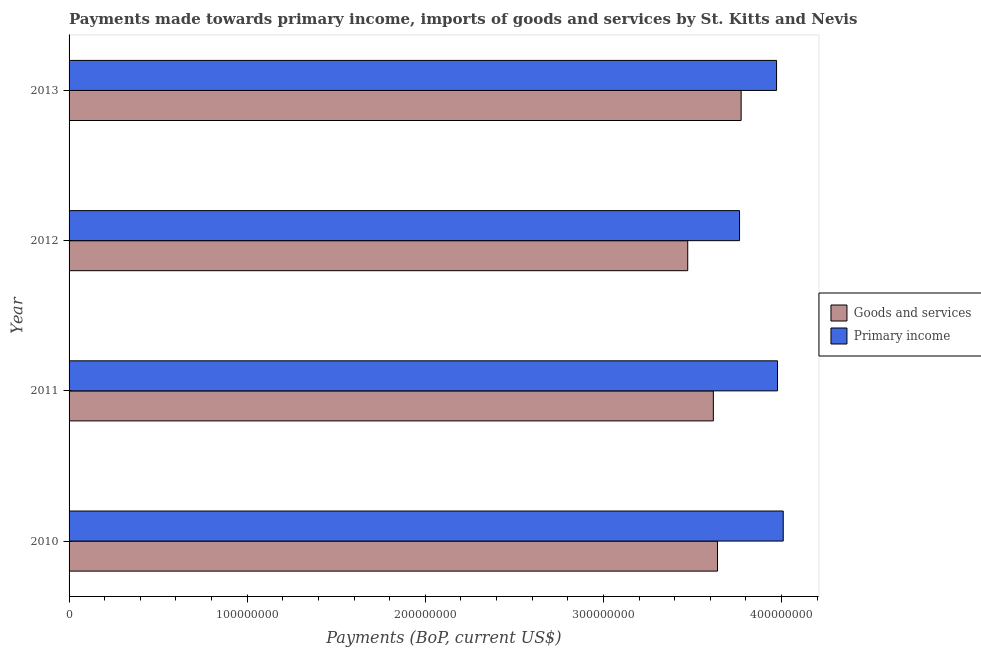How many groups of bars are there?
Offer a terse response. 4. Are the number of bars on each tick of the Y-axis equal?
Keep it short and to the point. Yes. How many bars are there on the 1st tick from the top?
Your response must be concise. 2. What is the label of the 2nd group of bars from the top?
Ensure brevity in your answer.  2012. In how many cases, is the number of bars for a given year not equal to the number of legend labels?
Make the answer very short. 0. What is the payments made towards goods and services in 2013?
Your answer should be very brief. 3.77e+08. Across all years, what is the maximum payments made towards primary income?
Your answer should be compact. 4.01e+08. Across all years, what is the minimum payments made towards primary income?
Give a very brief answer. 3.76e+08. In which year was the payments made towards goods and services maximum?
Make the answer very short. 2013. In which year was the payments made towards primary income minimum?
Provide a succinct answer. 2012. What is the total payments made towards primary income in the graph?
Provide a short and direct response. 1.57e+09. What is the difference between the payments made towards goods and services in 2011 and that in 2012?
Keep it short and to the point. 1.44e+07. What is the difference between the payments made towards primary income in 2011 and the payments made towards goods and services in 2013?
Give a very brief answer. 2.04e+07. What is the average payments made towards goods and services per year?
Give a very brief answer. 3.63e+08. In the year 2012, what is the difference between the payments made towards primary income and payments made towards goods and services?
Keep it short and to the point. 2.91e+07. Is the payments made towards primary income in 2010 less than that in 2013?
Your response must be concise. No. Is the difference between the payments made towards goods and services in 2010 and 2012 greater than the difference between the payments made towards primary income in 2010 and 2012?
Your answer should be very brief. No. What is the difference between the highest and the second highest payments made towards primary income?
Ensure brevity in your answer.  3.21e+06. What is the difference between the highest and the lowest payments made towards goods and services?
Offer a terse response. 3.00e+07. What does the 1st bar from the top in 2012 represents?
Offer a very short reply. Primary income. What does the 1st bar from the bottom in 2013 represents?
Your answer should be compact. Goods and services. Are all the bars in the graph horizontal?
Your answer should be compact. Yes. How many years are there in the graph?
Provide a short and direct response. 4. What is the difference between two consecutive major ticks on the X-axis?
Give a very brief answer. 1.00e+08. Are the values on the major ticks of X-axis written in scientific E-notation?
Make the answer very short. No. Does the graph contain any zero values?
Provide a short and direct response. No. How many legend labels are there?
Ensure brevity in your answer.  2. What is the title of the graph?
Provide a succinct answer. Payments made towards primary income, imports of goods and services by St. Kitts and Nevis. Does "Agricultural land" appear as one of the legend labels in the graph?
Provide a short and direct response. No. What is the label or title of the X-axis?
Your answer should be compact. Payments (BoP, current US$). What is the Payments (BoP, current US$) in Goods and services in 2010?
Keep it short and to the point. 3.64e+08. What is the Payments (BoP, current US$) of Primary income in 2010?
Your response must be concise. 4.01e+08. What is the Payments (BoP, current US$) of Goods and services in 2011?
Provide a succinct answer. 3.62e+08. What is the Payments (BoP, current US$) in Primary income in 2011?
Provide a succinct answer. 3.98e+08. What is the Payments (BoP, current US$) of Goods and services in 2012?
Ensure brevity in your answer.  3.47e+08. What is the Payments (BoP, current US$) in Primary income in 2012?
Provide a short and direct response. 3.76e+08. What is the Payments (BoP, current US$) in Goods and services in 2013?
Provide a short and direct response. 3.77e+08. What is the Payments (BoP, current US$) of Primary income in 2013?
Your answer should be compact. 3.97e+08. Across all years, what is the maximum Payments (BoP, current US$) of Goods and services?
Your answer should be compact. 3.77e+08. Across all years, what is the maximum Payments (BoP, current US$) of Primary income?
Offer a terse response. 4.01e+08. Across all years, what is the minimum Payments (BoP, current US$) in Goods and services?
Your answer should be very brief. 3.47e+08. Across all years, what is the minimum Payments (BoP, current US$) in Primary income?
Ensure brevity in your answer.  3.76e+08. What is the total Payments (BoP, current US$) in Goods and services in the graph?
Give a very brief answer. 1.45e+09. What is the total Payments (BoP, current US$) in Primary income in the graph?
Make the answer very short. 1.57e+09. What is the difference between the Payments (BoP, current US$) in Goods and services in 2010 and that in 2011?
Your response must be concise. 2.35e+06. What is the difference between the Payments (BoP, current US$) in Primary income in 2010 and that in 2011?
Ensure brevity in your answer.  3.21e+06. What is the difference between the Payments (BoP, current US$) of Goods and services in 2010 and that in 2012?
Keep it short and to the point. 1.67e+07. What is the difference between the Payments (BoP, current US$) of Primary income in 2010 and that in 2012?
Provide a succinct answer. 2.45e+07. What is the difference between the Payments (BoP, current US$) of Goods and services in 2010 and that in 2013?
Offer a terse response. -1.33e+07. What is the difference between the Payments (BoP, current US$) in Primary income in 2010 and that in 2013?
Your response must be concise. 3.75e+06. What is the difference between the Payments (BoP, current US$) of Goods and services in 2011 and that in 2012?
Keep it short and to the point. 1.44e+07. What is the difference between the Payments (BoP, current US$) in Primary income in 2011 and that in 2012?
Keep it short and to the point. 2.13e+07. What is the difference between the Payments (BoP, current US$) of Goods and services in 2011 and that in 2013?
Keep it short and to the point. -1.56e+07. What is the difference between the Payments (BoP, current US$) of Primary income in 2011 and that in 2013?
Your answer should be compact. 5.39e+05. What is the difference between the Payments (BoP, current US$) in Goods and services in 2012 and that in 2013?
Ensure brevity in your answer.  -3.00e+07. What is the difference between the Payments (BoP, current US$) in Primary income in 2012 and that in 2013?
Make the answer very short. -2.08e+07. What is the difference between the Payments (BoP, current US$) of Goods and services in 2010 and the Payments (BoP, current US$) of Primary income in 2011?
Provide a succinct answer. -3.37e+07. What is the difference between the Payments (BoP, current US$) of Goods and services in 2010 and the Payments (BoP, current US$) of Primary income in 2012?
Offer a very short reply. -1.24e+07. What is the difference between the Payments (BoP, current US$) of Goods and services in 2010 and the Payments (BoP, current US$) of Primary income in 2013?
Keep it short and to the point. -3.31e+07. What is the difference between the Payments (BoP, current US$) of Goods and services in 2011 and the Payments (BoP, current US$) of Primary income in 2012?
Keep it short and to the point. -1.47e+07. What is the difference between the Payments (BoP, current US$) of Goods and services in 2011 and the Payments (BoP, current US$) of Primary income in 2013?
Provide a succinct answer. -3.55e+07. What is the difference between the Payments (BoP, current US$) in Goods and services in 2012 and the Payments (BoP, current US$) in Primary income in 2013?
Your response must be concise. -4.99e+07. What is the average Payments (BoP, current US$) in Goods and services per year?
Give a very brief answer. 3.63e+08. What is the average Payments (BoP, current US$) in Primary income per year?
Keep it short and to the point. 3.93e+08. In the year 2010, what is the difference between the Payments (BoP, current US$) of Goods and services and Payments (BoP, current US$) of Primary income?
Provide a succinct answer. -3.69e+07. In the year 2011, what is the difference between the Payments (BoP, current US$) in Goods and services and Payments (BoP, current US$) in Primary income?
Your answer should be very brief. -3.60e+07. In the year 2012, what is the difference between the Payments (BoP, current US$) in Goods and services and Payments (BoP, current US$) in Primary income?
Make the answer very short. -2.91e+07. In the year 2013, what is the difference between the Payments (BoP, current US$) of Goods and services and Payments (BoP, current US$) of Primary income?
Your response must be concise. -1.99e+07. What is the ratio of the Payments (BoP, current US$) of Goods and services in 2010 to that in 2011?
Provide a succinct answer. 1.01. What is the ratio of the Payments (BoP, current US$) of Primary income in 2010 to that in 2011?
Your response must be concise. 1.01. What is the ratio of the Payments (BoP, current US$) of Goods and services in 2010 to that in 2012?
Offer a terse response. 1.05. What is the ratio of the Payments (BoP, current US$) of Primary income in 2010 to that in 2012?
Give a very brief answer. 1.07. What is the ratio of the Payments (BoP, current US$) in Goods and services in 2010 to that in 2013?
Provide a short and direct response. 0.96. What is the ratio of the Payments (BoP, current US$) of Primary income in 2010 to that in 2013?
Make the answer very short. 1.01. What is the ratio of the Payments (BoP, current US$) in Goods and services in 2011 to that in 2012?
Make the answer very short. 1.04. What is the ratio of the Payments (BoP, current US$) of Primary income in 2011 to that in 2012?
Your response must be concise. 1.06. What is the ratio of the Payments (BoP, current US$) of Goods and services in 2011 to that in 2013?
Your response must be concise. 0.96. What is the ratio of the Payments (BoP, current US$) of Goods and services in 2012 to that in 2013?
Provide a short and direct response. 0.92. What is the ratio of the Payments (BoP, current US$) in Primary income in 2012 to that in 2013?
Your answer should be compact. 0.95. What is the difference between the highest and the second highest Payments (BoP, current US$) of Goods and services?
Make the answer very short. 1.33e+07. What is the difference between the highest and the second highest Payments (BoP, current US$) of Primary income?
Give a very brief answer. 3.21e+06. What is the difference between the highest and the lowest Payments (BoP, current US$) of Goods and services?
Offer a terse response. 3.00e+07. What is the difference between the highest and the lowest Payments (BoP, current US$) of Primary income?
Provide a succinct answer. 2.45e+07. 